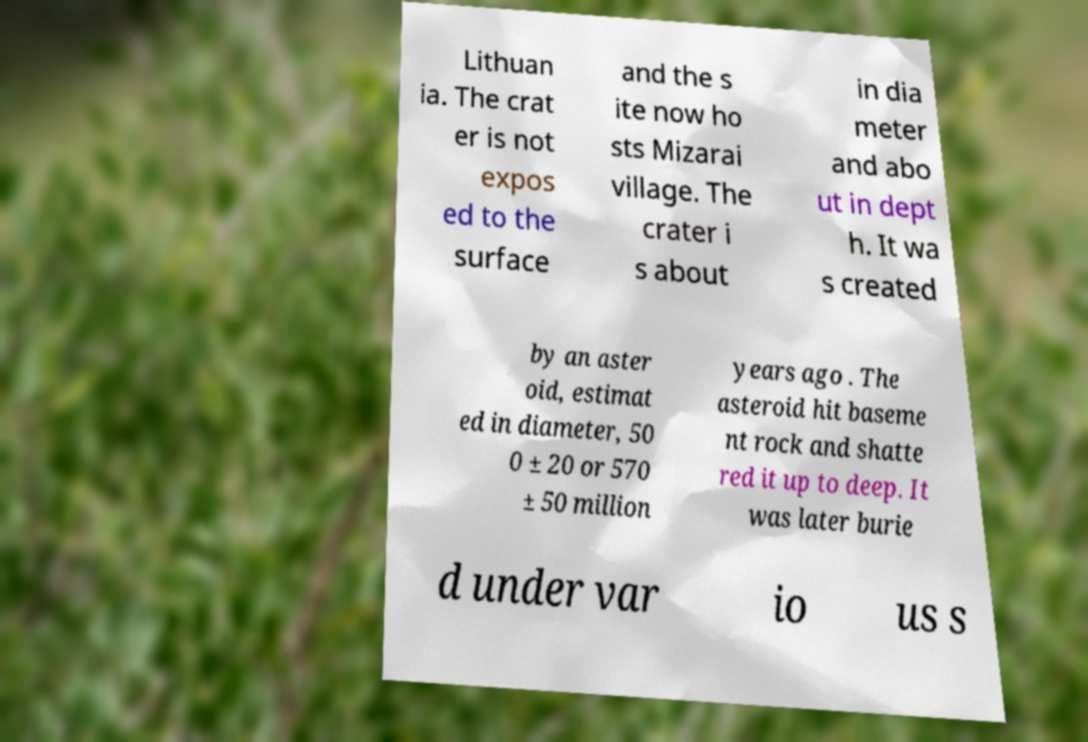Can you read and provide the text displayed in the image?This photo seems to have some interesting text. Can you extract and type it out for me? Lithuan ia. The crat er is not expos ed to the surface and the s ite now ho sts Mizarai village. The crater i s about in dia meter and abo ut in dept h. It wa s created by an aster oid, estimat ed in diameter, 50 0 ± 20 or 570 ± 50 million years ago . The asteroid hit baseme nt rock and shatte red it up to deep. It was later burie d under var io us s 